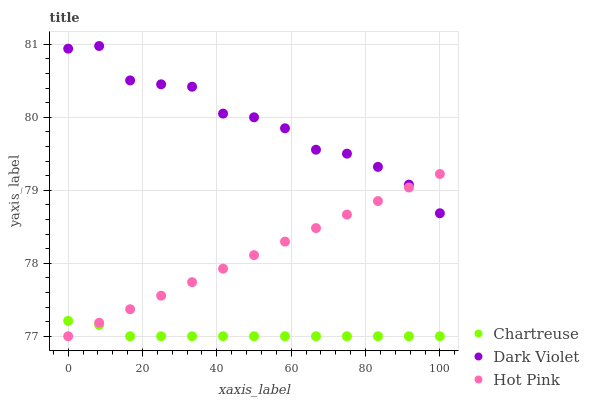Does Chartreuse have the minimum area under the curve?
Answer yes or no. Yes. Does Dark Violet have the maximum area under the curve?
Answer yes or no. Yes. Does Hot Pink have the minimum area under the curve?
Answer yes or no. No. Does Hot Pink have the maximum area under the curve?
Answer yes or no. No. Is Hot Pink the smoothest?
Answer yes or no. Yes. Is Dark Violet the roughest?
Answer yes or no. Yes. Is Dark Violet the smoothest?
Answer yes or no. No. Is Hot Pink the roughest?
Answer yes or no. No. Does Chartreuse have the lowest value?
Answer yes or no. Yes. Does Dark Violet have the lowest value?
Answer yes or no. No. Does Dark Violet have the highest value?
Answer yes or no. Yes. Does Hot Pink have the highest value?
Answer yes or no. No. Is Chartreuse less than Dark Violet?
Answer yes or no. Yes. Is Dark Violet greater than Chartreuse?
Answer yes or no. Yes. Does Hot Pink intersect Chartreuse?
Answer yes or no. Yes. Is Hot Pink less than Chartreuse?
Answer yes or no. No. Is Hot Pink greater than Chartreuse?
Answer yes or no. No. Does Chartreuse intersect Dark Violet?
Answer yes or no. No. 